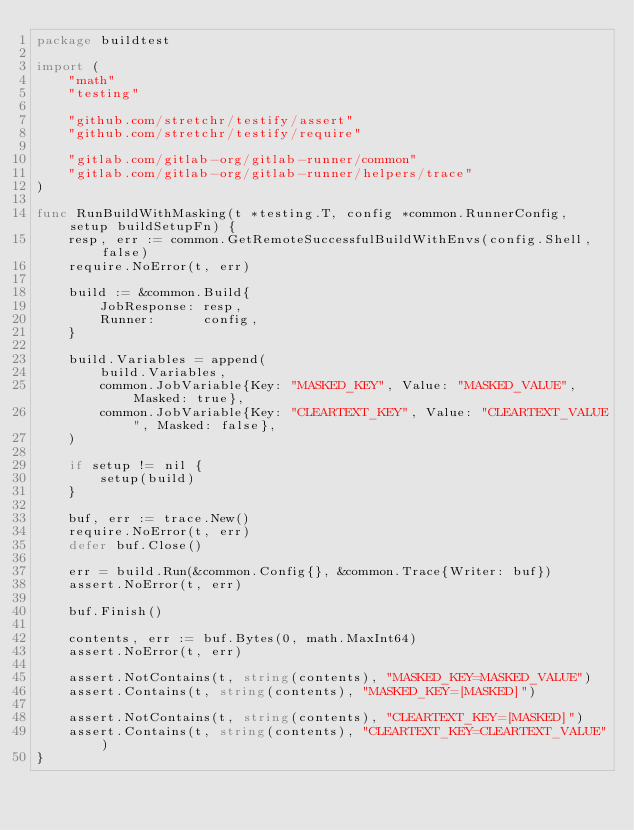<code> <loc_0><loc_0><loc_500><loc_500><_Go_>package buildtest

import (
	"math"
	"testing"

	"github.com/stretchr/testify/assert"
	"github.com/stretchr/testify/require"

	"gitlab.com/gitlab-org/gitlab-runner/common"
	"gitlab.com/gitlab-org/gitlab-runner/helpers/trace"
)

func RunBuildWithMasking(t *testing.T, config *common.RunnerConfig, setup buildSetupFn) {
	resp, err := common.GetRemoteSuccessfulBuildWithEnvs(config.Shell, false)
	require.NoError(t, err)

	build := &common.Build{
		JobResponse: resp,
		Runner:      config,
	}

	build.Variables = append(
		build.Variables,
		common.JobVariable{Key: "MASKED_KEY", Value: "MASKED_VALUE", Masked: true},
		common.JobVariable{Key: "CLEARTEXT_KEY", Value: "CLEARTEXT_VALUE", Masked: false},
	)

	if setup != nil {
		setup(build)
	}

	buf, err := trace.New()
	require.NoError(t, err)
	defer buf.Close()

	err = build.Run(&common.Config{}, &common.Trace{Writer: buf})
	assert.NoError(t, err)

	buf.Finish()

	contents, err := buf.Bytes(0, math.MaxInt64)
	assert.NoError(t, err)

	assert.NotContains(t, string(contents), "MASKED_KEY=MASKED_VALUE")
	assert.Contains(t, string(contents), "MASKED_KEY=[MASKED]")

	assert.NotContains(t, string(contents), "CLEARTEXT_KEY=[MASKED]")
	assert.Contains(t, string(contents), "CLEARTEXT_KEY=CLEARTEXT_VALUE")
}
</code> 